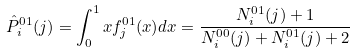Convert formula to latex. <formula><loc_0><loc_0><loc_500><loc_500>\hat { P } ^ { 0 1 } _ { i } ( j ) = \int _ { 0 } ^ { 1 } x f ^ { 0 1 } _ { j } ( x ) d x = \frac { N ^ { 0 1 } _ { i } ( j ) + 1 } { N ^ { 0 0 } _ { i } ( j ) + N ^ { 0 1 } _ { i } ( j ) + 2 }</formula> 